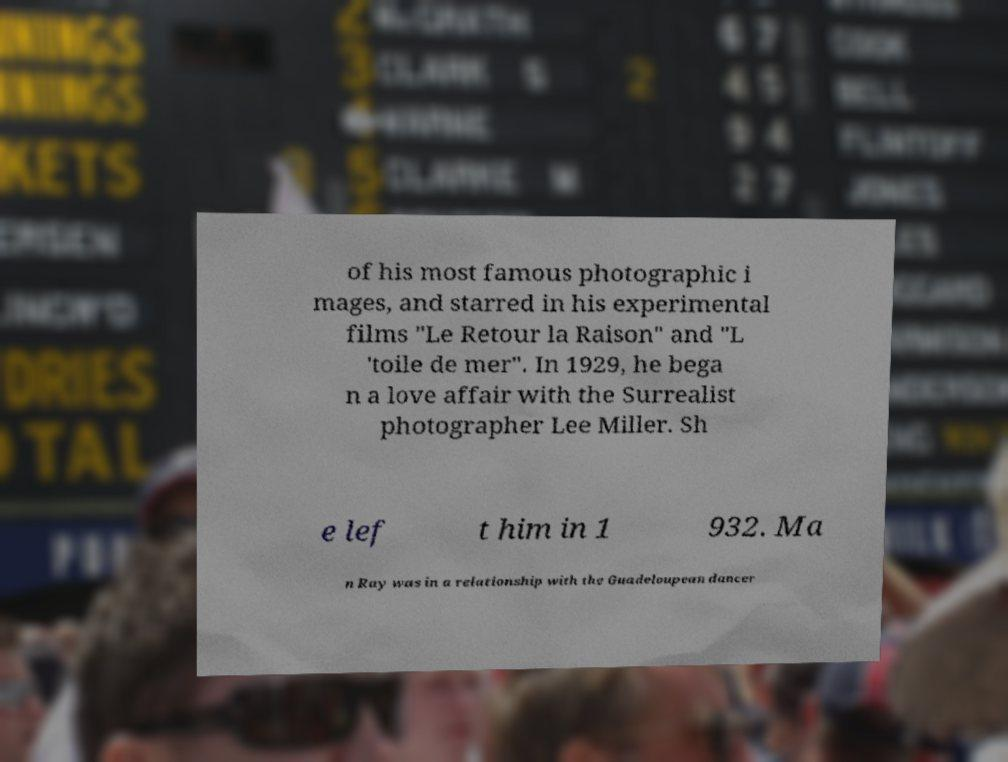Can you accurately transcribe the text from the provided image for me? of his most famous photographic i mages, and starred in his experimental films "Le Retour la Raison" and "L 'toile de mer". In 1929, he bega n a love affair with the Surrealist photographer Lee Miller. Sh e lef t him in 1 932. Ma n Ray was in a relationship with the Guadeloupean dancer 